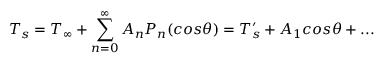<formula> <loc_0><loc_0><loc_500><loc_500>T _ { s } = T _ { \infty } + \sum _ { n = 0 } ^ { \infty } A _ { n } P _ { n } ( \cos \theta ) = { T _ { s } ^ { \prime } } + A _ { 1 } \cos \theta + \dots</formula> 